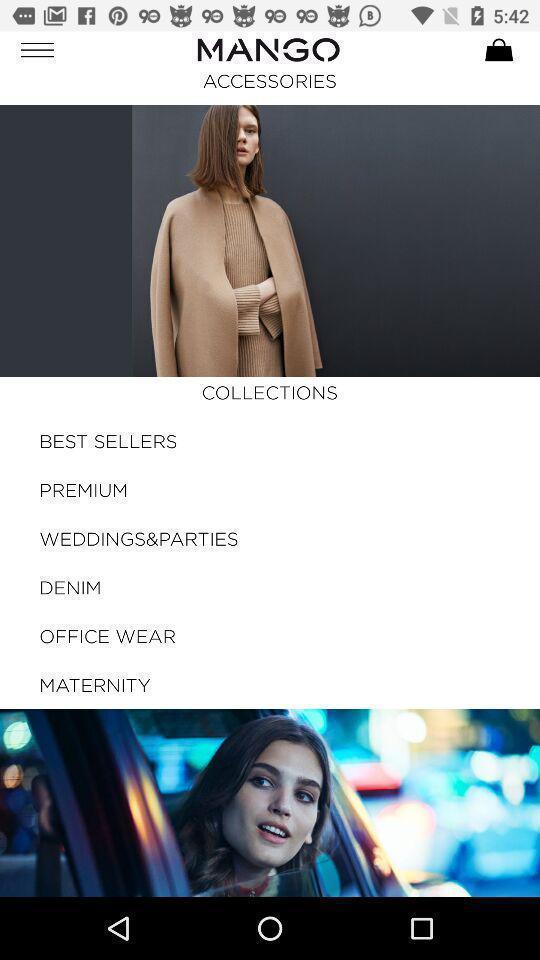Summarize the main components in this picture. Screen displaying the dresses collections in shopping app. 